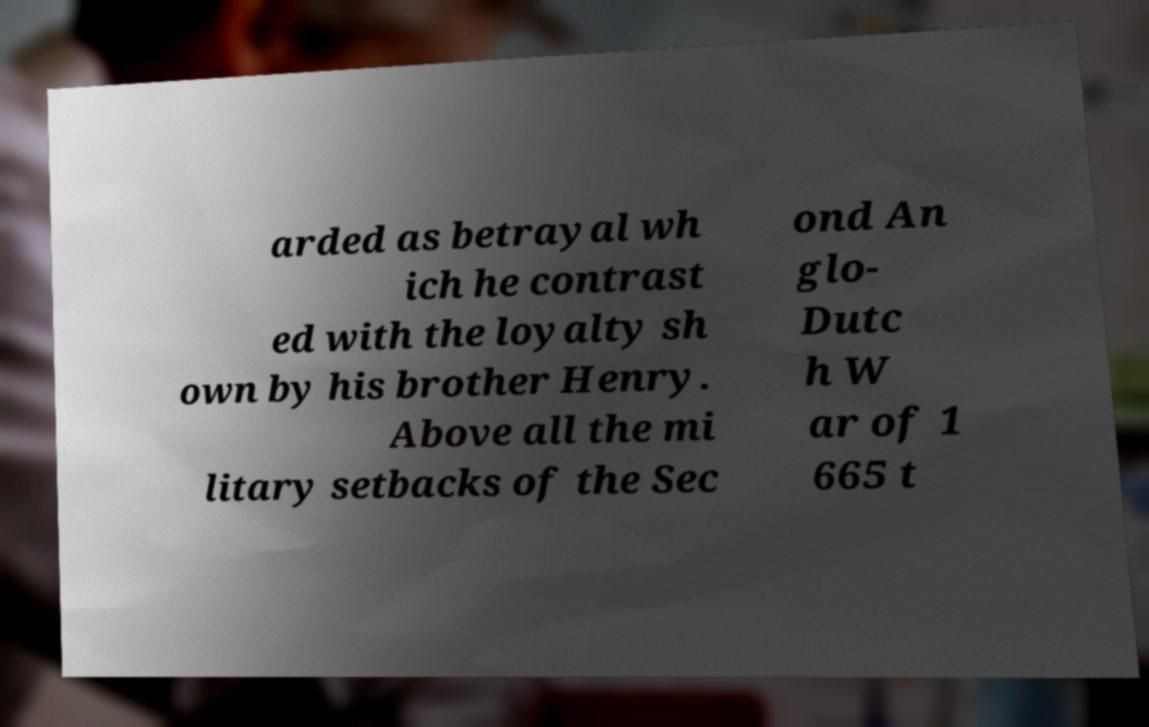For documentation purposes, I need the text within this image transcribed. Could you provide that? arded as betrayal wh ich he contrast ed with the loyalty sh own by his brother Henry. Above all the mi litary setbacks of the Sec ond An glo- Dutc h W ar of 1 665 t 